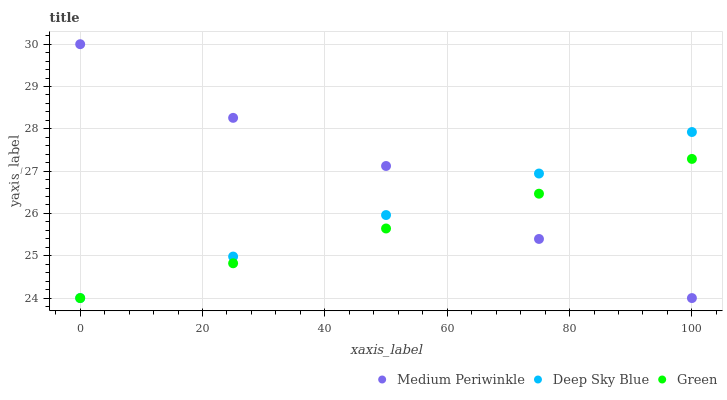Does Green have the minimum area under the curve?
Answer yes or no. Yes. Does Medium Periwinkle have the maximum area under the curve?
Answer yes or no. Yes. Does Deep Sky Blue have the minimum area under the curve?
Answer yes or no. No. Does Deep Sky Blue have the maximum area under the curve?
Answer yes or no. No. Is Green the smoothest?
Answer yes or no. Yes. Is Medium Periwinkle the roughest?
Answer yes or no. Yes. Is Deep Sky Blue the smoothest?
Answer yes or no. No. Is Deep Sky Blue the roughest?
Answer yes or no. No. Does Green have the lowest value?
Answer yes or no. Yes. Does Medium Periwinkle have the highest value?
Answer yes or no. Yes. Does Deep Sky Blue have the highest value?
Answer yes or no. No. Does Green intersect Deep Sky Blue?
Answer yes or no. Yes. Is Green less than Deep Sky Blue?
Answer yes or no. No. Is Green greater than Deep Sky Blue?
Answer yes or no. No. 